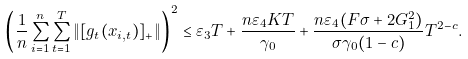Convert formula to latex. <formula><loc_0><loc_0><loc_500><loc_500>& \left ( \frac { 1 } { n } \sum _ { i = 1 } ^ { n } \sum _ { t = 1 } ^ { T } \| [ g _ { t } ( x _ { i , t } ) ] _ { + } \| \right ) ^ { 2 } \leq \varepsilon _ { 3 } T + \frac { n \varepsilon _ { 4 } K T } { \gamma _ { 0 } } + \frac { n \varepsilon _ { 4 } ( F \sigma + 2 G _ { 1 } ^ { 2 } ) } { \sigma \gamma _ { 0 } ( 1 - c ) } T ^ { 2 - c } .</formula> 